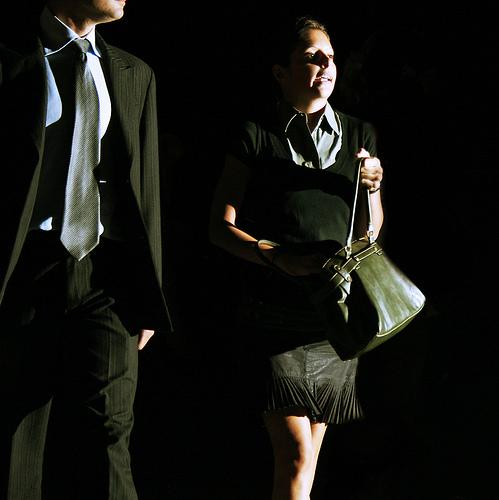What is the person on the left wearing? Please explain your reasoning. tie. The person has a tie. 